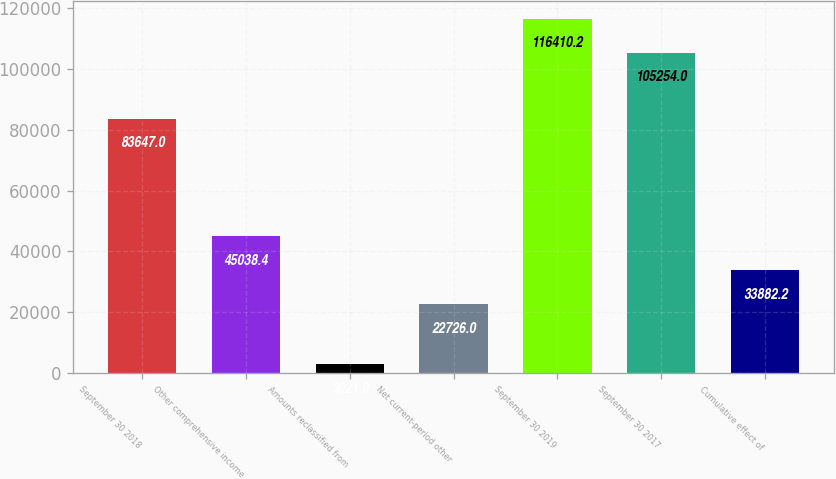Convert chart to OTSL. <chart><loc_0><loc_0><loc_500><loc_500><bar_chart><fcel>September 30 2018<fcel>Other comprehensive income<fcel>Amounts reclassified from<fcel>Net current-period other<fcel>September 30 2019<fcel>September 30 2017<fcel>Cumulative effect of<nl><fcel>83647<fcel>45038.4<fcel>3021<fcel>22726<fcel>116410<fcel>105254<fcel>33882.2<nl></chart> 